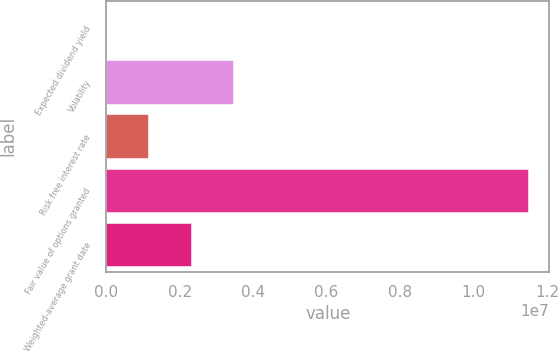Convert chart. <chart><loc_0><loc_0><loc_500><loc_500><bar_chart><fcel>Expected dividend yield<fcel>Volatility<fcel>Risk free interest rate<fcel>Fair value of options granted<fcel>Weighted-average grant date<nl><fcel>0.27<fcel>3.447e+06<fcel>1.149e+06<fcel>1.149e+07<fcel>2.298e+06<nl></chart> 